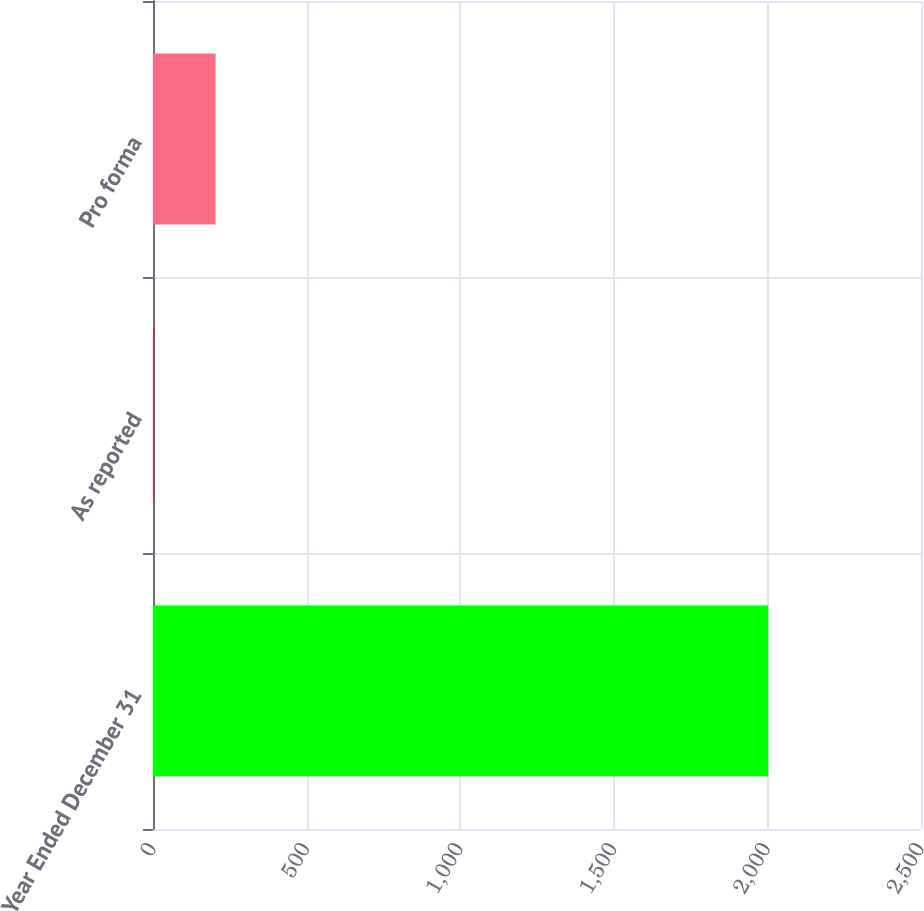Convert chart to OTSL. <chart><loc_0><loc_0><loc_500><loc_500><bar_chart><fcel>Year Ended December 31<fcel>As reported<fcel>Pro forma<nl><fcel>2003<fcel>3.84<fcel>203.76<nl></chart> 